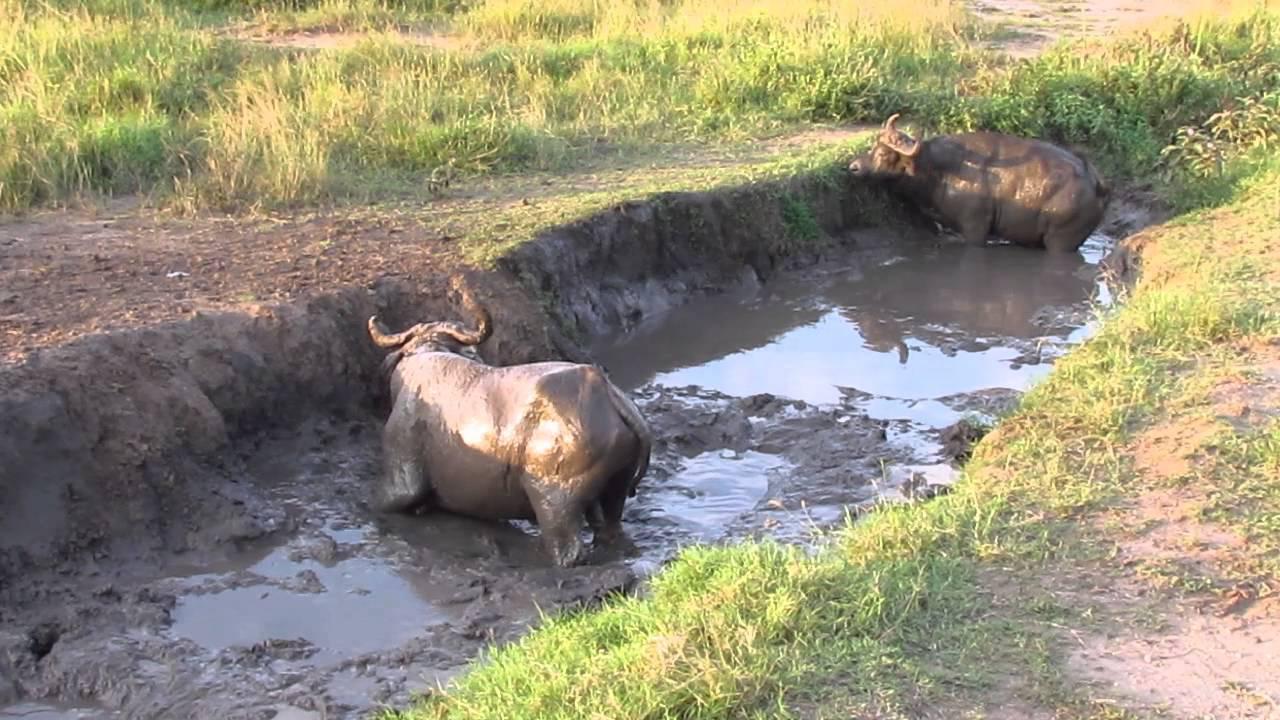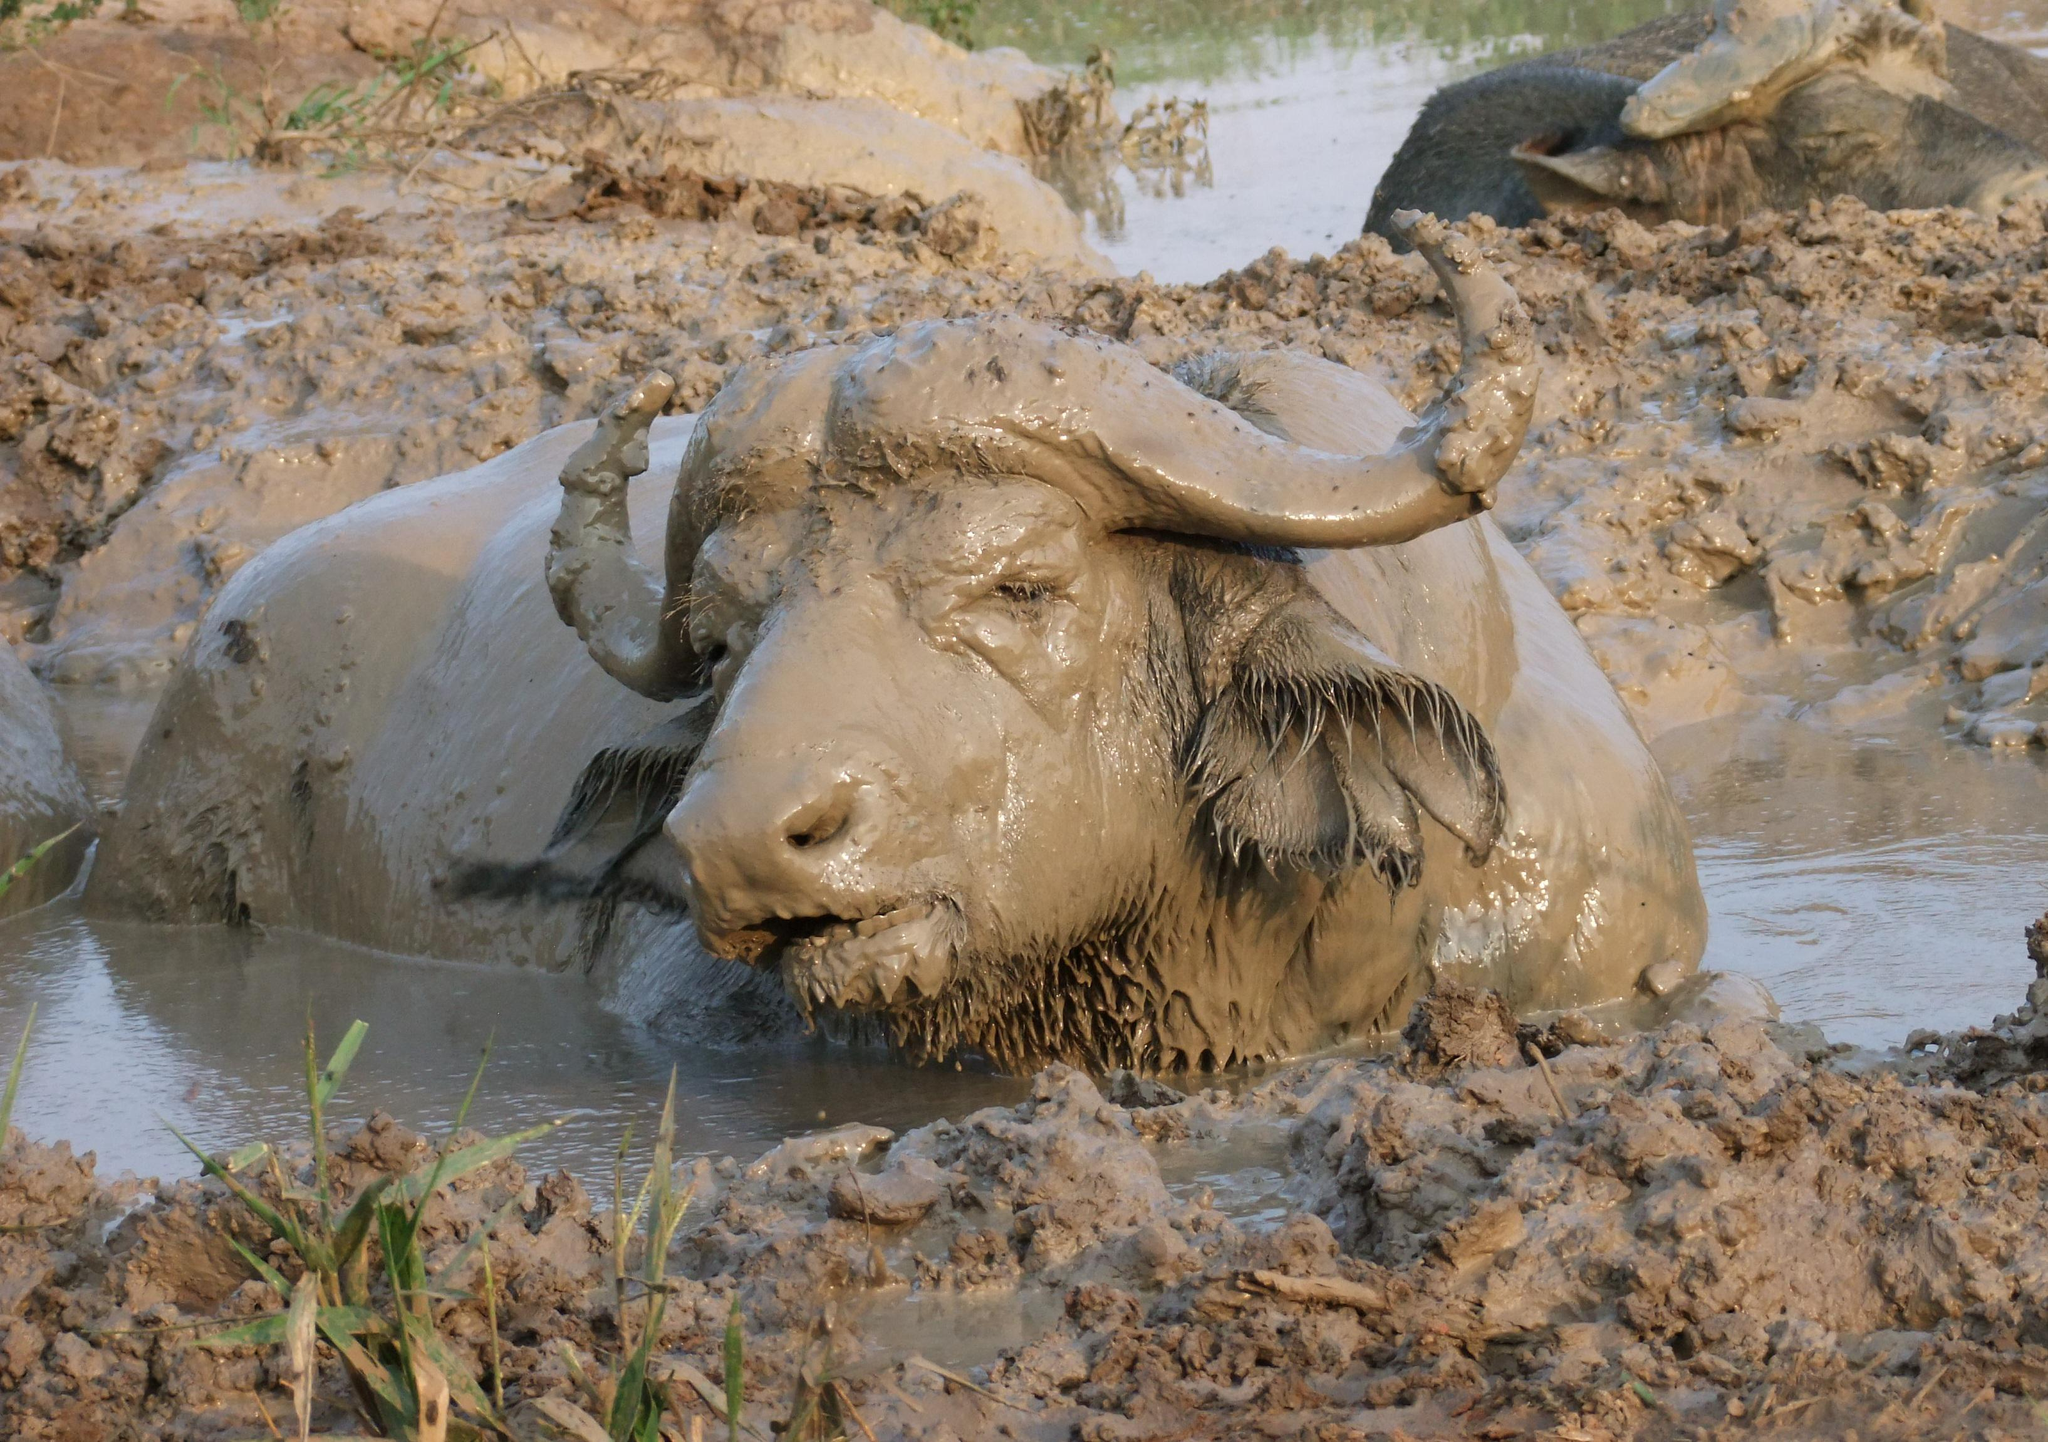The first image is the image on the left, the second image is the image on the right. Examine the images to the left and right. Is the description "The right image shows a single bull rolling on its back with legs in the air, while the left image shows a single bull wading through mud." accurate? Answer yes or no. No. The first image is the image on the left, the second image is the image on the right. Evaluate the accuracy of this statement regarding the images: "The right image shows one muddy water buffalo lying on its back with its hind legs extended up in the air.". Is it true? Answer yes or no. No. 